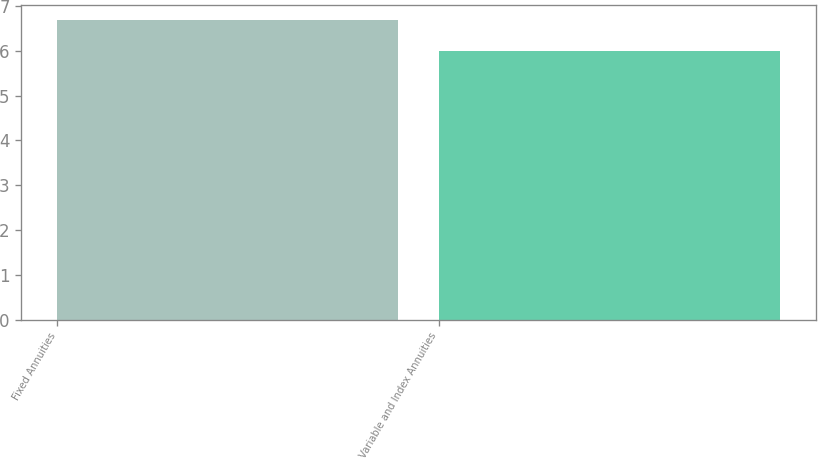Convert chart to OTSL. <chart><loc_0><loc_0><loc_500><loc_500><bar_chart><fcel>Fixed Annuities<fcel>Variable and Index Annuities<nl><fcel>6.7<fcel>6<nl></chart> 